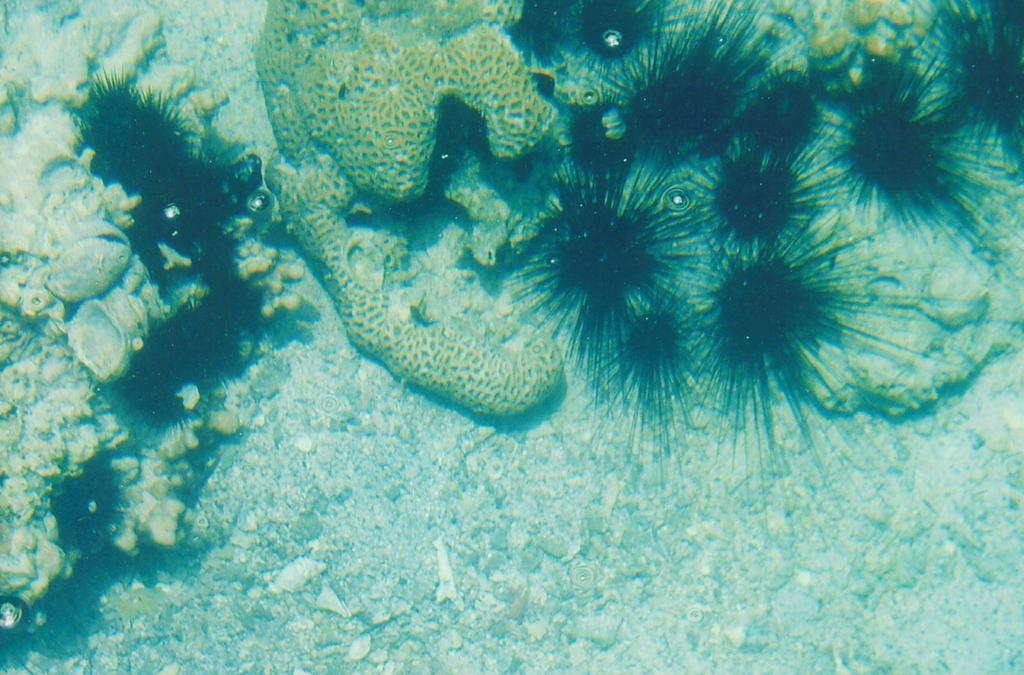Where was the image taken? The image was taken in the sea. What can be seen underwater in the image? There are many coral reefs in the water. Are there any other objects visible in the image? Yes, there are a few stones in the image. What type of spoon can be seen floating in the water in the image? There is no spoon present in the image; it only features coral reefs and stones. 